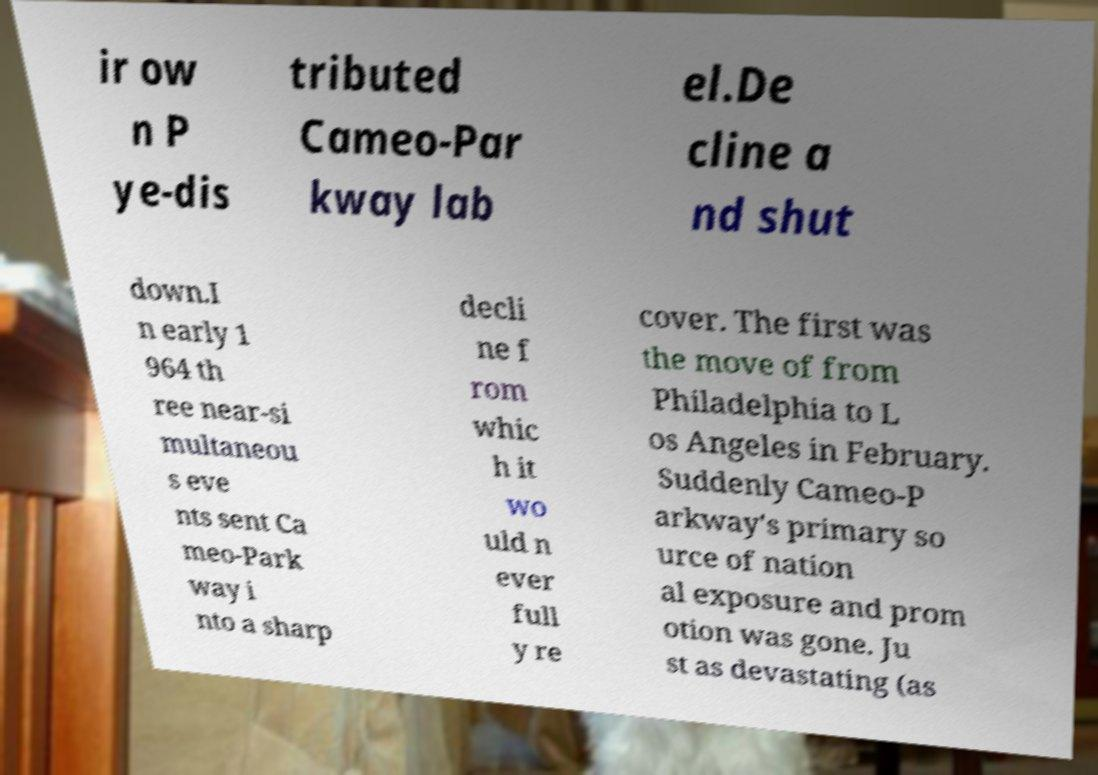Can you accurately transcribe the text from the provided image for me? ir ow n P ye-dis tributed Cameo-Par kway lab el.De cline a nd shut down.I n early 1 964 th ree near-si multaneou s eve nts sent Ca meo-Park way i nto a sharp decli ne f rom whic h it wo uld n ever full y re cover. The first was the move of from Philadelphia to L os Angeles in February. Suddenly Cameo-P arkway's primary so urce of nation al exposure and prom otion was gone. Ju st as devastating (as 